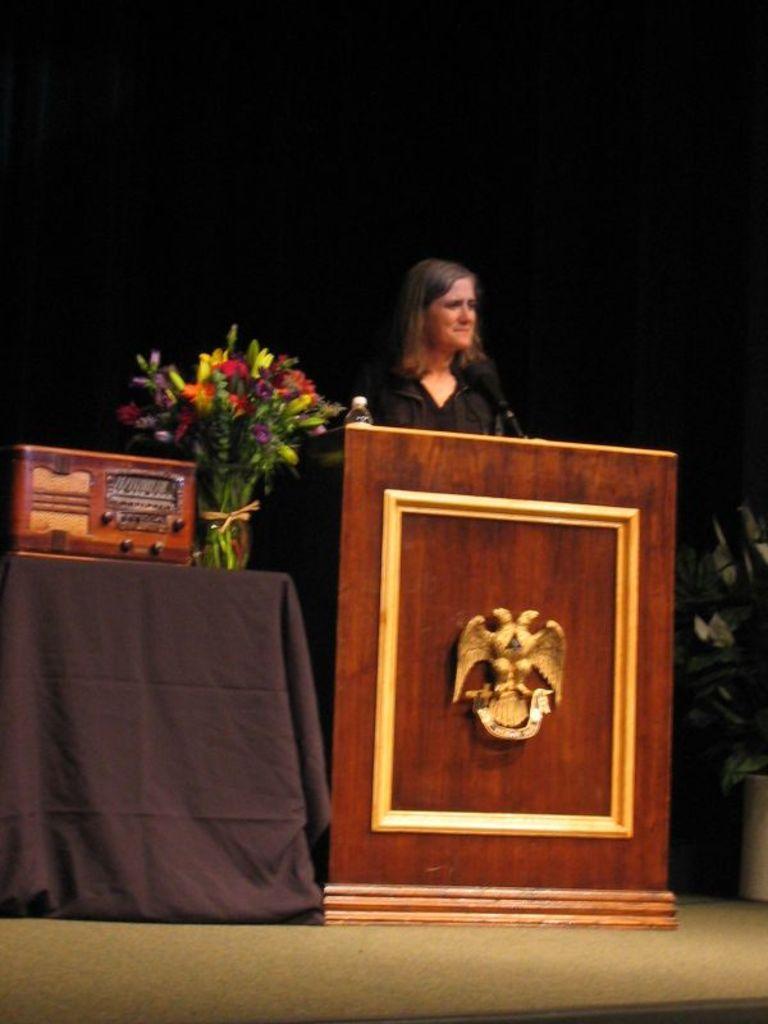In one or two sentences, can you explain what this image depicts? In this image I can see a woman is standing and I can see she is wearing black colour of dress. In the front of her I can see a podium and on it I can see a water bottle and a mic. On the left side of the image I can see a black colour cloth, a brown colour thing and different types of flowers. On the right side of the image I can see a plant in the pot and I can also see black colour in the background. 